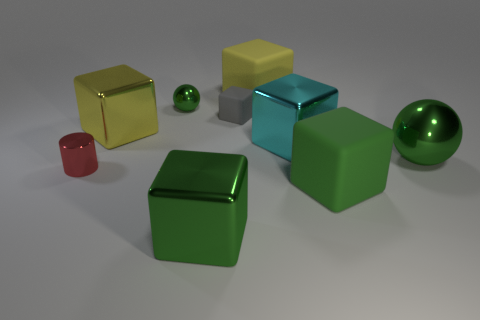What number of cubes are either gray rubber things or tiny things?
Ensure brevity in your answer.  1. What number of gray objects are made of the same material as the large cyan cube?
Keep it short and to the point. 0. Do the cyan object on the left side of the large ball and the small cube that is to the right of the cylinder have the same material?
Give a very brief answer. No. What number of big rubber blocks are right of the big shiny block to the right of the big matte block behind the small shiny sphere?
Provide a succinct answer. 1. There is a large matte object that is left of the cyan thing; is it the same color as the large thing left of the green metallic block?
Keep it short and to the point. Yes. Is there anything else that has the same color as the tiny shiny ball?
Your answer should be very brief. Yes. There is a large matte cube that is in front of the large yellow object behind the small gray rubber object; what is its color?
Keep it short and to the point. Green. Is there a small red rubber sphere?
Your response must be concise. No. What color is the big object that is both to the left of the cyan thing and in front of the red cylinder?
Provide a short and direct response. Green. There is a green sphere that is behind the big green ball; is its size the same as the red metal cylinder that is left of the large yellow rubber block?
Give a very brief answer. Yes. 